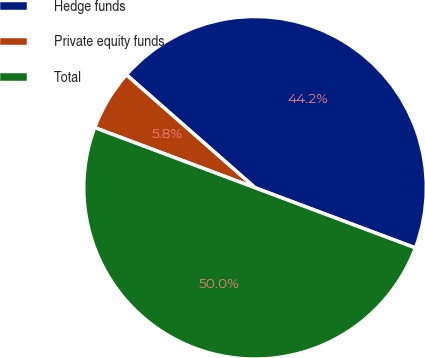<chart> <loc_0><loc_0><loc_500><loc_500><pie_chart><fcel>Hedge funds<fcel>Private equity funds<fcel>Total<nl><fcel>44.24%<fcel>5.76%<fcel>50.0%<nl></chart> 